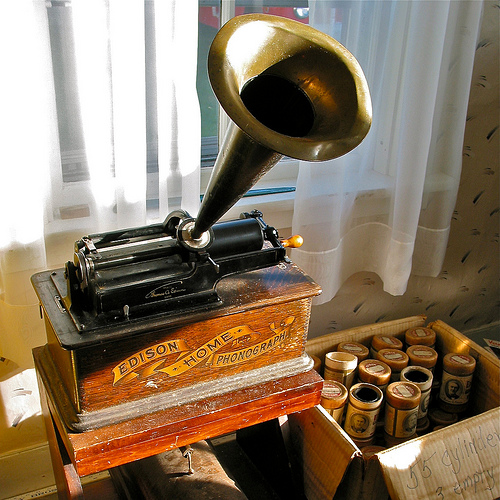<image>
Is the phonograph on the box? Yes. Looking at the image, I can see the phonograph is positioned on top of the box, with the box providing support. 